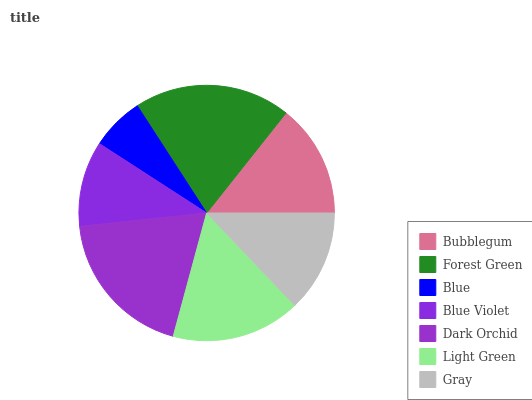Is Blue the minimum?
Answer yes or no. Yes. Is Forest Green the maximum?
Answer yes or no. Yes. Is Forest Green the minimum?
Answer yes or no. No. Is Blue the maximum?
Answer yes or no. No. Is Forest Green greater than Blue?
Answer yes or no. Yes. Is Blue less than Forest Green?
Answer yes or no. Yes. Is Blue greater than Forest Green?
Answer yes or no. No. Is Forest Green less than Blue?
Answer yes or no. No. Is Bubblegum the high median?
Answer yes or no. Yes. Is Bubblegum the low median?
Answer yes or no. Yes. Is Gray the high median?
Answer yes or no. No. Is Forest Green the low median?
Answer yes or no. No. 